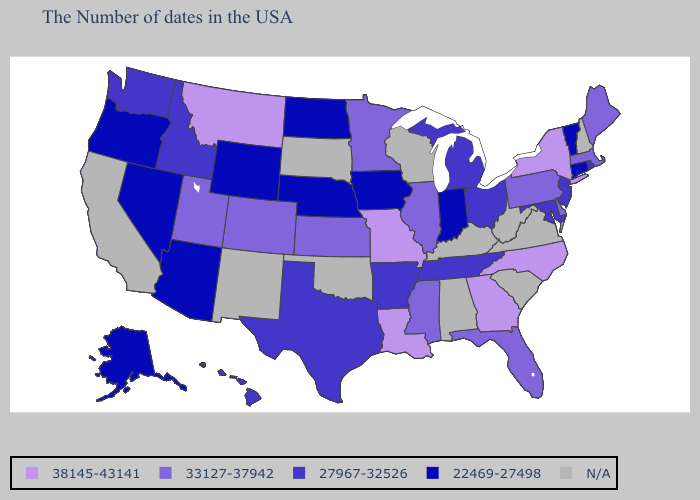Name the states that have a value in the range 38145-43141?
Quick response, please. New York, North Carolina, Georgia, Louisiana, Missouri, Montana. What is the value of Colorado?
Keep it brief. 33127-37942. Name the states that have a value in the range N/A?
Concise answer only. New Hampshire, Virginia, South Carolina, West Virginia, Kentucky, Alabama, Wisconsin, Oklahoma, South Dakota, New Mexico, California. Name the states that have a value in the range 22469-27498?
Quick response, please. Vermont, Connecticut, Indiana, Iowa, Nebraska, North Dakota, Wyoming, Arizona, Nevada, Oregon, Alaska. Name the states that have a value in the range N/A?
Answer briefly. New Hampshire, Virginia, South Carolina, West Virginia, Kentucky, Alabama, Wisconsin, Oklahoma, South Dakota, New Mexico, California. What is the value of Nevada?
Give a very brief answer. 22469-27498. Name the states that have a value in the range 38145-43141?
Write a very short answer. New York, North Carolina, Georgia, Louisiana, Missouri, Montana. Is the legend a continuous bar?
Quick response, please. No. Is the legend a continuous bar?
Quick response, please. No. Name the states that have a value in the range 38145-43141?
Keep it brief. New York, North Carolina, Georgia, Louisiana, Missouri, Montana. Which states have the highest value in the USA?
Quick response, please. New York, North Carolina, Georgia, Louisiana, Missouri, Montana. Is the legend a continuous bar?
Short answer required. No. Name the states that have a value in the range 38145-43141?
Concise answer only. New York, North Carolina, Georgia, Louisiana, Missouri, Montana. 